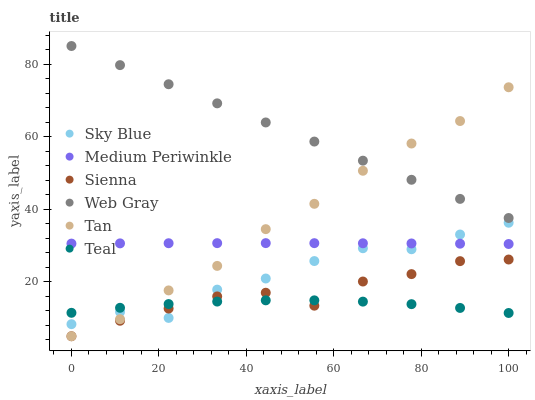Does Teal have the minimum area under the curve?
Answer yes or no. Yes. Does Web Gray have the maximum area under the curve?
Answer yes or no. Yes. Does Medium Periwinkle have the minimum area under the curve?
Answer yes or no. No. Does Medium Periwinkle have the maximum area under the curve?
Answer yes or no. No. Is Web Gray the smoothest?
Answer yes or no. Yes. Is Sky Blue the roughest?
Answer yes or no. Yes. Is Medium Periwinkle the smoothest?
Answer yes or no. No. Is Medium Periwinkle the roughest?
Answer yes or no. No. Does Sienna have the lowest value?
Answer yes or no. Yes. Does Medium Periwinkle have the lowest value?
Answer yes or no. No. Does Web Gray have the highest value?
Answer yes or no. Yes. Does Medium Periwinkle have the highest value?
Answer yes or no. No. Is Sienna less than Web Gray?
Answer yes or no. Yes. Is Web Gray greater than Sienna?
Answer yes or no. Yes. Does Tan intersect Medium Periwinkle?
Answer yes or no. Yes. Is Tan less than Medium Periwinkle?
Answer yes or no. No. Is Tan greater than Medium Periwinkle?
Answer yes or no. No. Does Sienna intersect Web Gray?
Answer yes or no. No. 